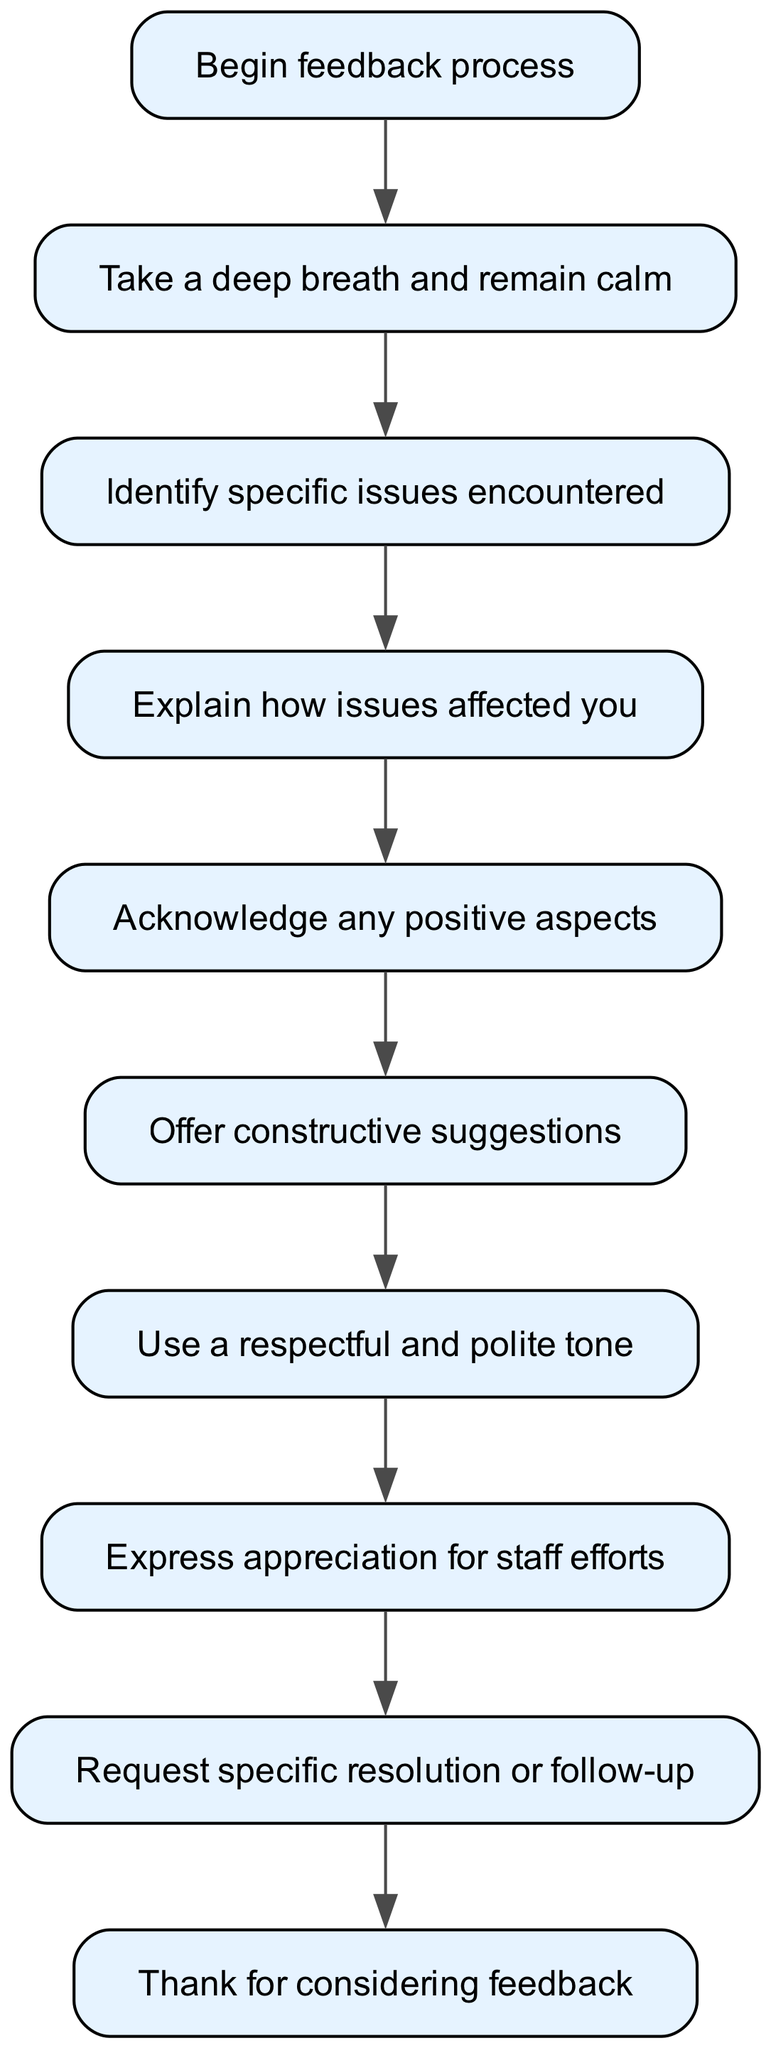What is the first step in the feedback process? The first step in the process, indicated in the diagram, is labeled "Begin feedback process."
Answer: Begin feedback process How many nodes are there in the diagram? The diagram comprises 10 nodes, as each unique step in the feedback process is represented as a node.
Answer: 10 What is the last step after expressing appreciation for staff efforts? Following the step labeled "Express appreciation for staff efforts," the next and final step in the process is "Thank for considering feedback."
Answer: Thank for considering feedback What does the node after “Identify specific issues encountered” represent? The node that follows "Identify specific issues encountered" represents the step "Explain how issues affected you," guiding the user to elaborate on the impact of the issues.
Answer: Explain how issues affected you How is the tone suggested to be during feedback? According to the diagram, the suggested tone during feedback is "Use a respectful and polite tone," indicating the importance of politeness in the feedback process.
Answer: Use a respectful and polite tone What type of suggestions should be offered? The diagram states that the suggestions to be offered should be "constructive suggestions," highlighting the need for positive and actionable feedback.
Answer: Constructive suggestions Which two steps must be completed prior to requesting a specific resolution? The steps that must be completed prior to requesting a specific resolution are "Express appreciation for staff efforts" and "Use a respectful and polite tone." These are prerequisites to ensure a considerate approach before making a request.
Answer: Express appreciation for staff efforts and Use a respectful and polite tone What is the relationship between “Acknowledge any positive aspects” and “Offer constructive suggestions”? In the flow of the diagram, "Acknowledge any positive aspects" comes directly before "Offer constructive suggestions," indicating that recognizing positive elements should precede presenting suggestions for improvement.
Answer: Acknowledge any positive aspects comes before Offer constructive suggestions How many connections link the nodes in the diagram? The diagram consists of 9 connections, needed to illustrate the flow from each step to its subsequent action.
Answer: 9 